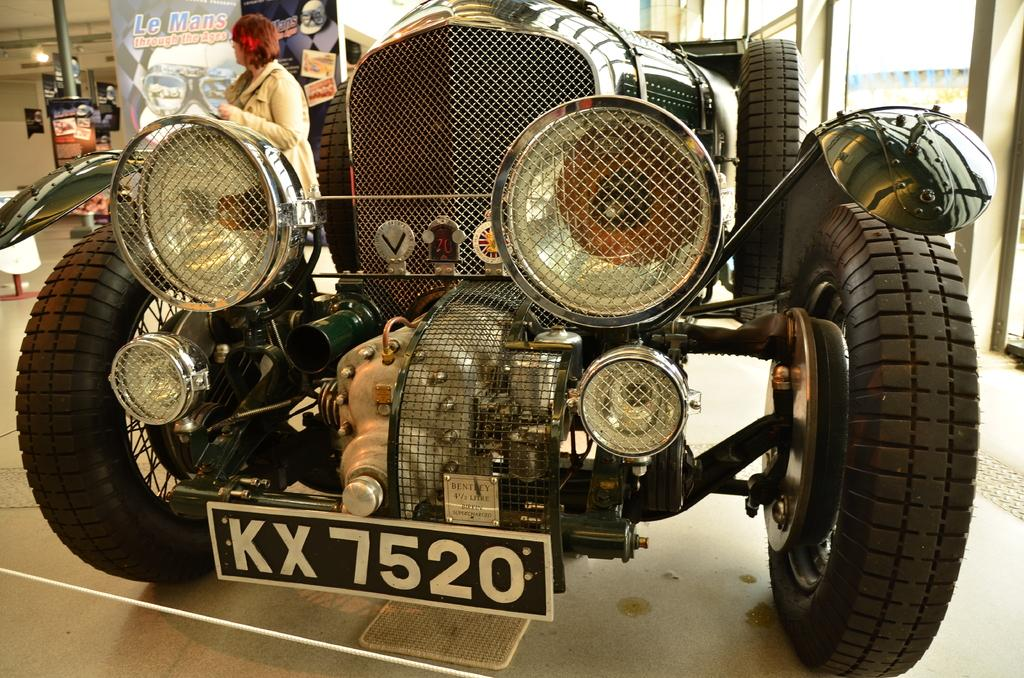What is the main subject in the image? There is a vehicle in the image. Can you describe the woman's position in relation to the vehicle? There is a woman visible beside the vehicle. What other object can be seen in the image? There is a pole in the image. What is the light's location in the image? There is a light on the left side of the image. What type of music is the group playing in the image? There is no group or music present in the image; it features a vehicle, a woman, a pole, and a light. 